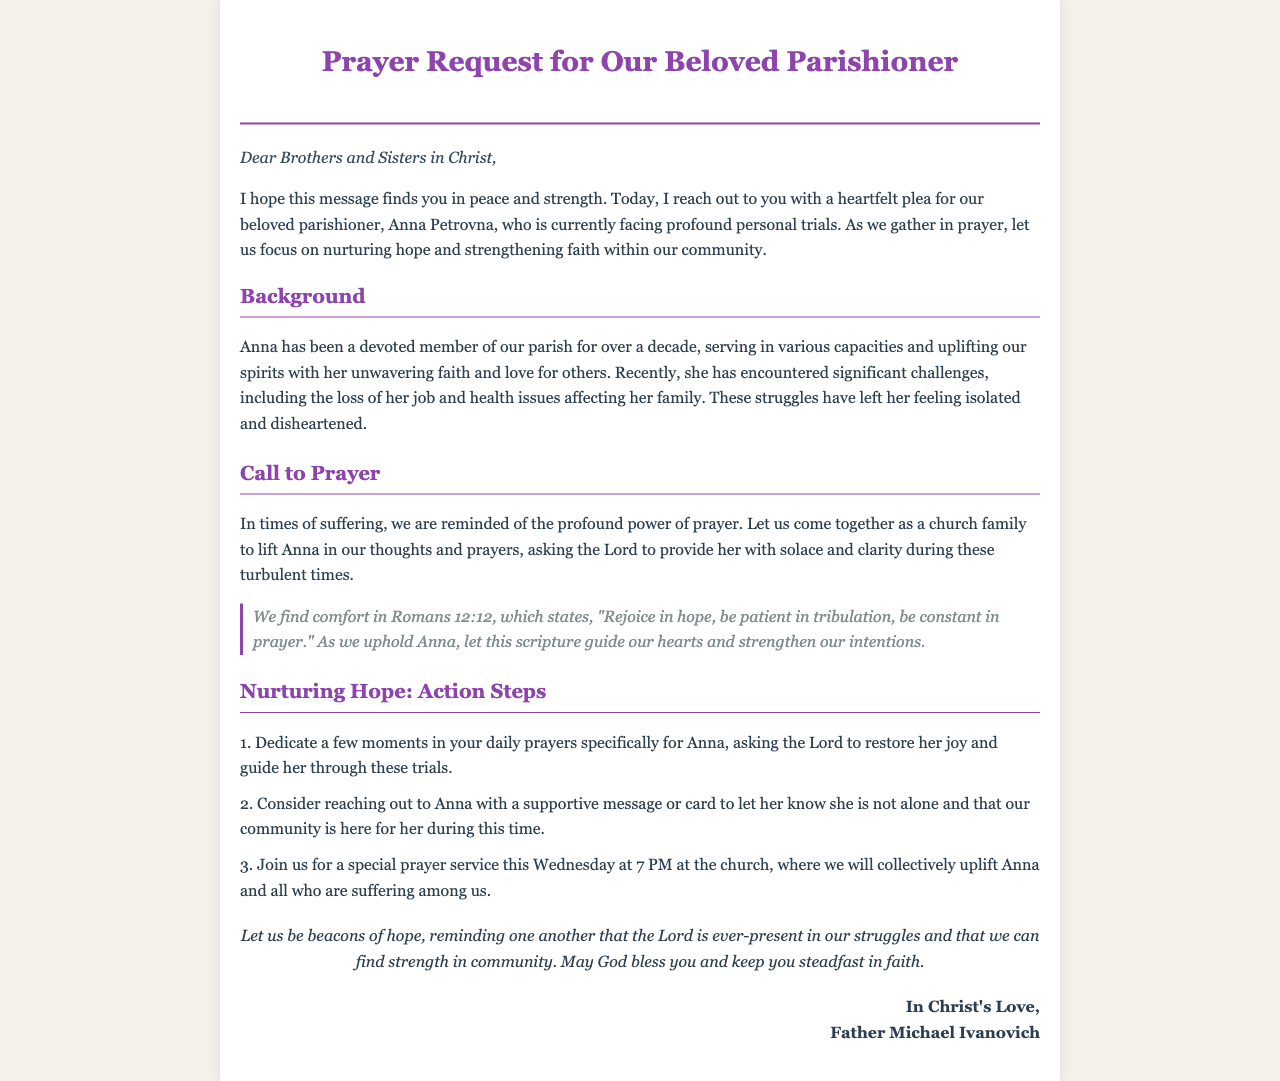What is the name of the parishioner in need of prayer? The document addresses Anna Petrovna as the parishioner facing challenges.
Answer: Anna Petrovna How long has Anna been a member of the parish? The document states that Anna has been a devoted member for over a decade.
Answer: over a decade What significant challenges is Anna facing? The document mentions a loss of her job and health issues affecting her family.
Answer: loss of her job and health issues What scripture is mentioned to provide comfort? The document quotes Romans 12:12 to provide guidance for prayer and hope.
Answer: Romans 12:12 What time is the special prayer service scheduled for? The document specifies that the prayer service is set for 7 PM on Wednesday.
Answer: 7 PM What should community members do in their daily prayers? The document encourages dedicating moments in daily prayers specifically for Anna.
Answer: Pray for Anna What is one way to support Anna mentioned in the document? The document suggests reaching out with a supportive message or card.
Answer: Reach out with a message Who signed the prayer request? The document is signed by Father Michael Ivanovich.
Answer: Father Michael Ivanovich 